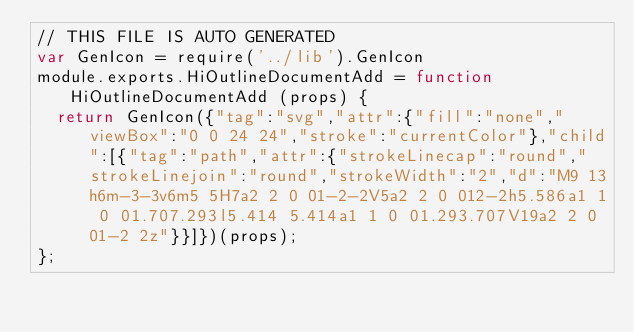Convert code to text. <code><loc_0><loc_0><loc_500><loc_500><_JavaScript_>// THIS FILE IS AUTO GENERATED
var GenIcon = require('../lib').GenIcon
module.exports.HiOutlineDocumentAdd = function HiOutlineDocumentAdd (props) {
  return GenIcon({"tag":"svg","attr":{"fill":"none","viewBox":"0 0 24 24","stroke":"currentColor"},"child":[{"tag":"path","attr":{"strokeLinecap":"round","strokeLinejoin":"round","strokeWidth":"2","d":"M9 13h6m-3-3v6m5 5H7a2 2 0 01-2-2V5a2 2 0 012-2h5.586a1 1 0 01.707.293l5.414 5.414a1 1 0 01.293.707V19a2 2 0 01-2 2z"}}]})(props);
};
</code> 